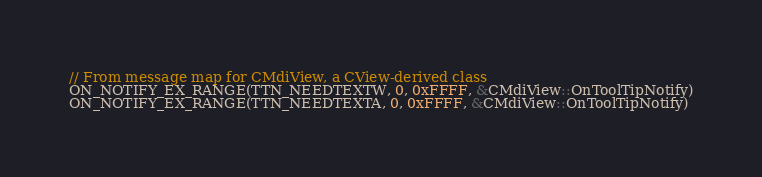<code> <loc_0><loc_0><loc_500><loc_500><_C++_>// From message map for CMdiView, a CView-derived class
ON_NOTIFY_EX_RANGE(TTN_NEEDTEXTW, 0, 0xFFFF, &CMdiView::OnToolTipNotify)
ON_NOTIFY_EX_RANGE(TTN_NEEDTEXTA, 0, 0xFFFF, &CMdiView::OnToolTipNotify)</code> 